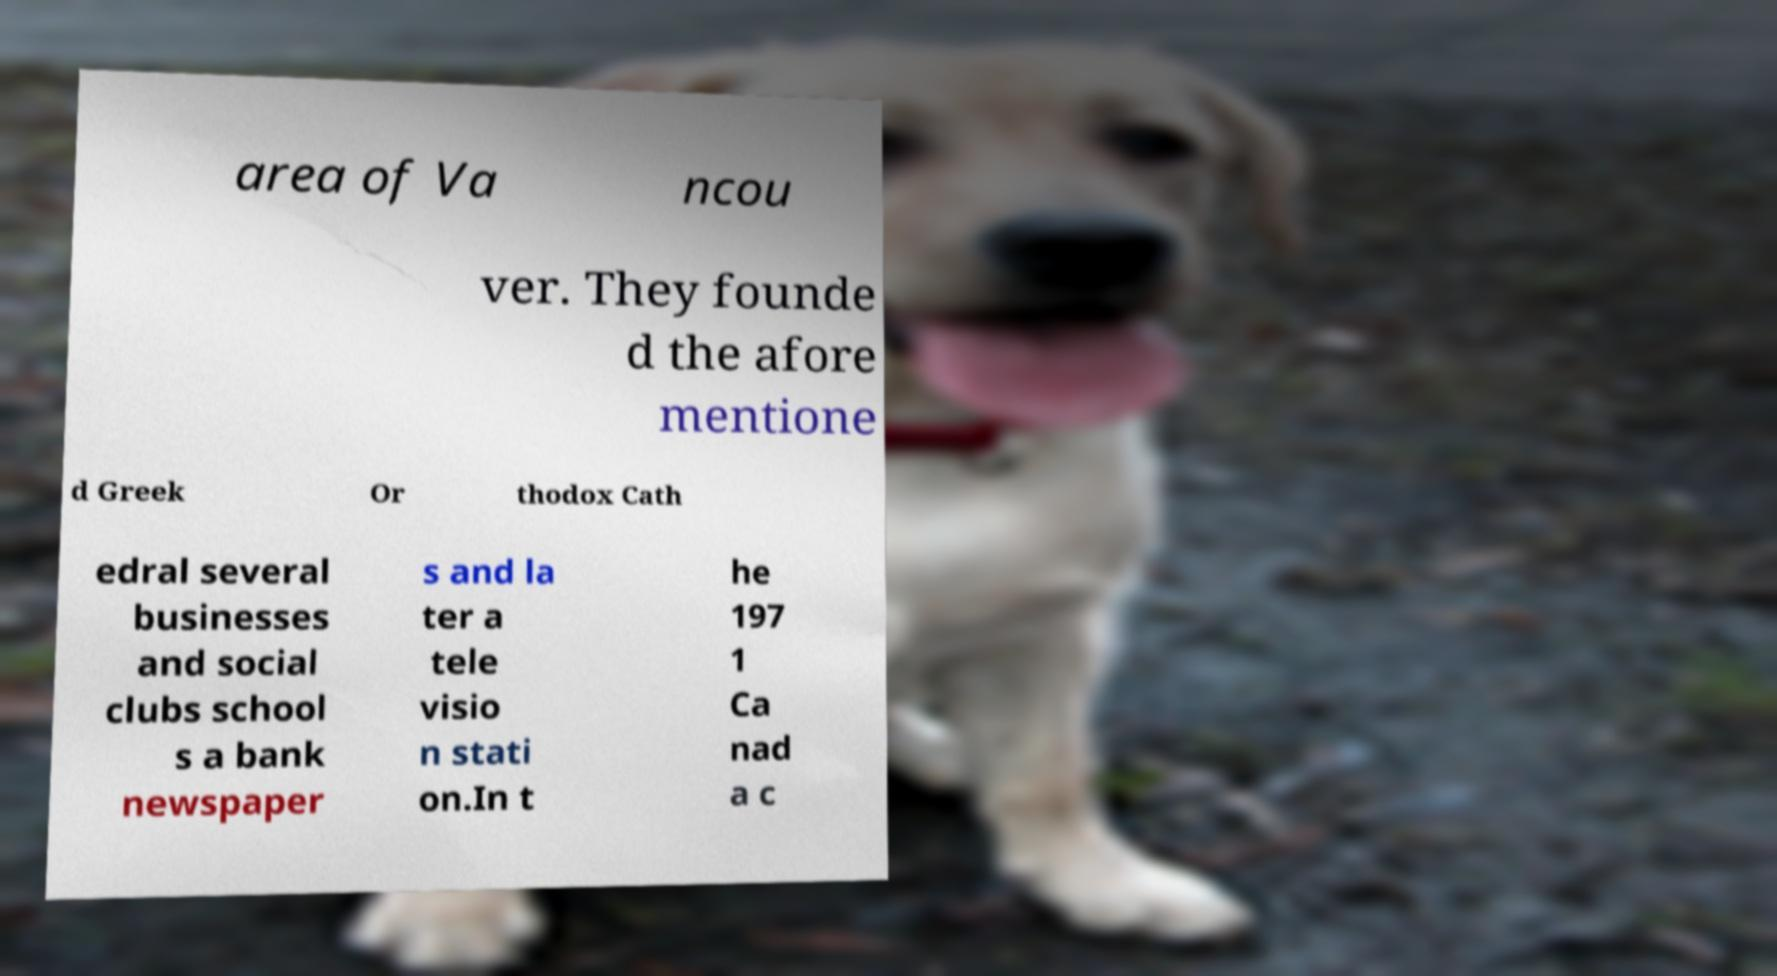Please identify and transcribe the text found in this image. area of Va ncou ver. They founde d the afore mentione d Greek Or thodox Cath edral several businesses and social clubs school s a bank newspaper s and la ter a tele visio n stati on.In t he 197 1 Ca nad a c 